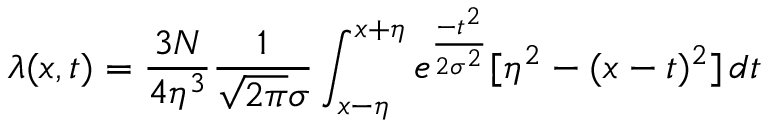Convert formula to latex. <formula><loc_0><loc_0><loc_500><loc_500>\lambda ( x , t ) = \frac { 3 N } { 4 \eta ^ { 3 } } \frac { 1 } { \sqrt { 2 \pi } \sigma } \int _ { x - \eta } ^ { x + \eta } e ^ { \frac { - t ^ { 2 } } { 2 \sigma ^ { 2 } } } [ \eta ^ { 2 } - ( x - t ) ^ { 2 } ] \, d t</formula> 